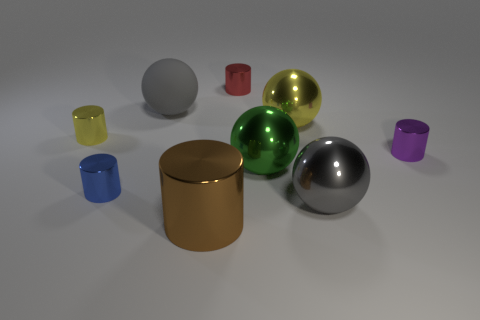Subtract all yellow blocks. How many gray balls are left? 2 Subtract all blue metallic cylinders. How many cylinders are left? 4 Add 1 small blue rubber balls. How many objects exist? 10 Subtract 2 cylinders. How many cylinders are left? 3 Subtract all yellow cylinders. How many cylinders are left? 4 Subtract all balls. How many objects are left? 5 Subtract all brown balls. Subtract all blue cylinders. How many balls are left? 4 Subtract 0 cyan cylinders. How many objects are left? 9 Subtract all small brown metal objects. Subtract all green shiny spheres. How many objects are left? 8 Add 5 large yellow objects. How many large yellow objects are left? 6 